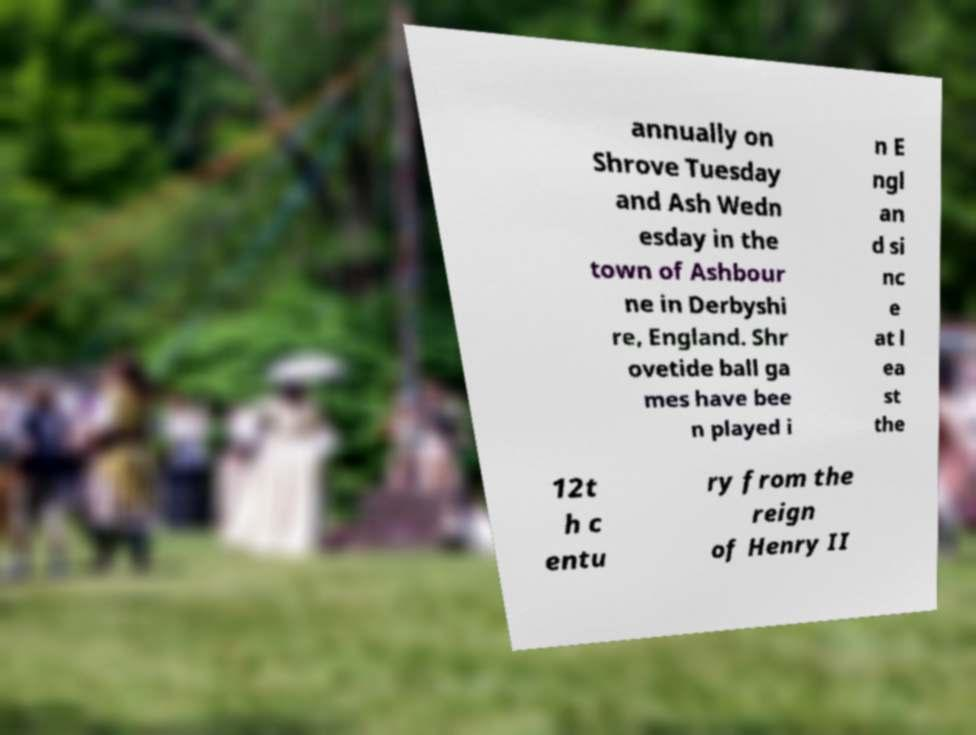What messages or text are displayed in this image? I need them in a readable, typed format. annually on Shrove Tuesday and Ash Wedn esday in the town of Ashbour ne in Derbyshi re, England. Shr ovetide ball ga mes have bee n played i n E ngl an d si nc e at l ea st the 12t h c entu ry from the reign of Henry II 